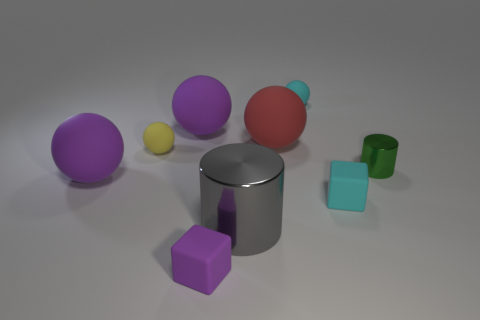There is a large metal cylinder; does it have the same color as the large sphere in front of the small shiny cylinder?
Your response must be concise. No. Is there a cyan rubber thing that has the same shape as the tiny shiny thing?
Provide a succinct answer. No. What number of things are either gray shiny cylinders or large purple objects left of the yellow ball?
Make the answer very short. 2. What number of other things are the same material as the tiny purple thing?
Offer a very short reply. 6. How many things are either big green metallic cylinders or cylinders?
Ensure brevity in your answer.  2. Is the number of blocks behind the small cyan matte block greater than the number of purple matte things in front of the tiny yellow rubber object?
Provide a short and direct response. No. Does the small block that is to the left of the tiny cyan cube have the same color as the big ball that is in front of the green metal thing?
Your answer should be compact. Yes. There is a shiny thing that is behind the metallic thing that is on the left side of the small cyan ball that is on the right side of the big red ball; what size is it?
Offer a very short reply. Small. What is the color of the other tiny object that is the same shape as the yellow rubber object?
Make the answer very short. Cyan. Are there more big gray things right of the tiny cyan cube than cyan rubber cubes?
Your answer should be very brief. No. 